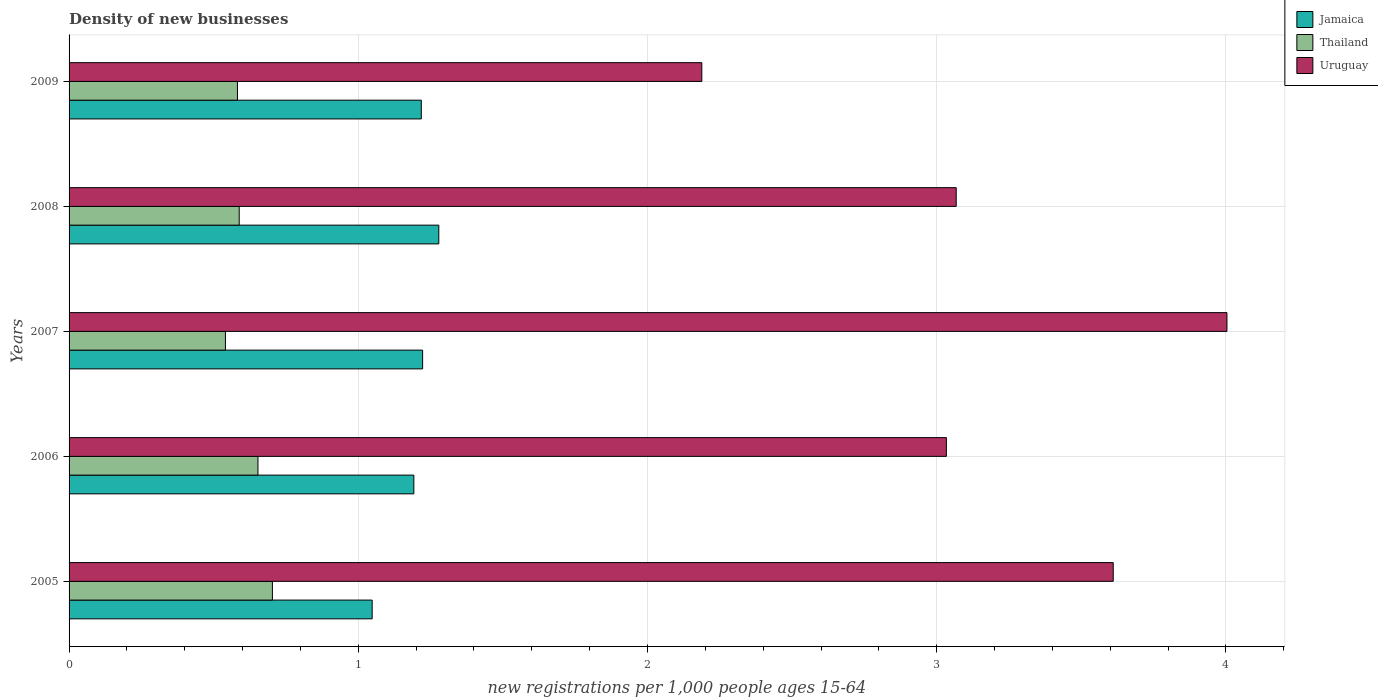How many different coloured bars are there?
Offer a very short reply. 3. Are the number of bars per tick equal to the number of legend labels?
Your response must be concise. Yes. How many bars are there on the 5th tick from the top?
Ensure brevity in your answer.  3. How many bars are there on the 1st tick from the bottom?
Keep it short and to the point. 3. In how many cases, is the number of bars for a given year not equal to the number of legend labels?
Ensure brevity in your answer.  0. What is the number of new registrations in Jamaica in 2007?
Provide a short and direct response. 1.22. Across all years, what is the maximum number of new registrations in Thailand?
Provide a short and direct response. 0.7. Across all years, what is the minimum number of new registrations in Uruguay?
Keep it short and to the point. 2.19. In which year was the number of new registrations in Jamaica maximum?
Offer a terse response. 2008. What is the total number of new registrations in Jamaica in the graph?
Keep it short and to the point. 5.96. What is the difference between the number of new registrations in Thailand in 2006 and that in 2007?
Provide a short and direct response. 0.11. What is the difference between the number of new registrations in Thailand in 2006 and the number of new registrations in Uruguay in 2009?
Give a very brief answer. -1.53. What is the average number of new registrations in Jamaica per year?
Provide a succinct answer. 1.19. In the year 2009, what is the difference between the number of new registrations in Thailand and number of new registrations in Jamaica?
Your response must be concise. -0.64. In how many years, is the number of new registrations in Jamaica greater than 3.2 ?
Your answer should be compact. 0. What is the ratio of the number of new registrations in Thailand in 2006 to that in 2007?
Provide a short and direct response. 1.21. Is the difference between the number of new registrations in Thailand in 2005 and 2008 greater than the difference between the number of new registrations in Jamaica in 2005 and 2008?
Your answer should be compact. Yes. What is the difference between the highest and the second highest number of new registrations in Uruguay?
Your answer should be very brief. 0.39. What is the difference between the highest and the lowest number of new registrations in Jamaica?
Keep it short and to the point. 0.23. What does the 1st bar from the top in 2009 represents?
Ensure brevity in your answer.  Uruguay. What does the 2nd bar from the bottom in 2006 represents?
Give a very brief answer. Thailand. Is it the case that in every year, the sum of the number of new registrations in Uruguay and number of new registrations in Thailand is greater than the number of new registrations in Jamaica?
Make the answer very short. Yes. Are all the bars in the graph horizontal?
Your answer should be compact. Yes. What is the difference between two consecutive major ticks on the X-axis?
Your answer should be very brief. 1. Does the graph contain grids?
Offer a terse response. Yes. Where does the legend appear in the graph?
Ensure brevity in your answer.  Top right. How many legend labels are there?
Your answer should be compact. 3. What is the title of the graph?
Provide a short and direct response. Density of new businesses. What is the label or title of the X-axis?
Your answer should be very brief. New registrations per 1,0 people ages 15-64. What is the new registrations per 1,000 people ages 15-64 in Jamaica in 2005?
Your response must be concise. 1.05. What is the new registrations per 1,000 people ages 15-64 of Thailand in 2005?
Provide a succinct answer. 0.7. What is the new registrations per 1,000 people ages 15-64 in Uruguay in 2005?
Provide a succinct answer. 3.61. What is the new registrations per 1,000 people ages 15-64 of Jamaica in 2006?
Give a very brief answer. 1.19. What is the new registrations per 1,000 people ages 15-64 in Thailand in 2006?
Provide a short and direct response. 0.65. What is the new registrations per 1,000 people ages 15-64 in Uruguay in 2006?
Provide a succinct answer. 3.03. What is the new registrations per 1,000 people ages 15-64 of Jamaica in 2007?
Your answer should be compact. 1.22. What is the new registrations per 1,000 people ages 15-64 of Thailand in 2007?
Your answer should be compact. 0.54. What is the new registrations per 1,000 people ages 15-64 of Uruguay in 2007?
Give a very brief answer. 4. What is the new registrations per 1,000 people ages 15-64 of Jamaica in 2008?
Make the answer very short. 1.28. What is the new registrations per 1,000 people ages 15-64 of Thailand in 2008?
Ensure brevity in your answer.  0.59. What is the new registrations per 1,000 people ages 15-64 in Uruguay in 2008?
Ensure brevity in your answer.  3.07. What is the new registrations per 1,000 people ages 15-64 in Jamaica in 2009?
Provide a succinct answer. 1.22. What is the new registrations per 1,000 people ages 15-64 in Thailand in 2009?
Make the answer very short. 0.58. What is the new registrations per 1,000 people ages 15-64 in Uruguay in 2009?
Your response must be concise. 2.19. Across all years, what is the maximum new registrations per 1,000 people ages 15-64 in Jamaica?
Provide a succinct answer. 1.28. Across all years, what is the maximum new registrations per 1,000 people ages 15-64 in Thailand?
Offer a terse response. 0.7. Across all years, what is the maximum new registrations per 1,000 people ages 15-64 of Uruguay?
Give a very brief answer. 4. Across all years, what is the minimum new registrations per 1,000 people ages 15-64 of Jamaica?
Give a very brief answer. 1.05. Across all years, what is the minimum new registrations per 1,000 people ages 15-64 in Thailand?
Make the answer very short. 0.54. Across all years, what is the minimum new registrations per 1,000 people ages 15-64 in Uruguay?
Provide a short and direct response. 2.19. What is the total new registrations per 1,000 people ages 15-64 in Jamaica in the graph?
Keep it short and to the point. 5.96. What is the total new registrations per 1,000 people ages 15-64 in Thailand in the graph?
Your answer should be compact. 3.07. What is the total new registrations per 1,000 people ages 15-64 in Uruguay in the graph?
Offer a very short reply. 15.9. What is the difference between the new registrations per 1,000 people ages 15-64 of Jamaica in 2005 and that in 2006?
Ensure brevity in your answer.  -0.14. What is the difference between the new registrations per 1,000 people ages 15-64 in Thailand in 2005 and that in 2006?
Provide a short and direct response. 0.05. What is the difference between the new registrations per 1,000 people ages 15-64 of Uruguay in 2005 and that in 2006?
Offer a very short reply. 0.58. What is the difference between the new registrations per 1,000 people ages 15-64 in Jamaica in 2005 and that in 2007?
Your answer should be very brief. -0.17. What is the difference between the new registrations per 1,000 people ages 15-64 in Thailand in 2005 and that in 2007?
Offer a very short reply. 0.16. What is the difference between the new registrations per 1,000 people ages 15-64 in Uruguay in 2005 and that in 2007?
Ensure brevity in your answer.  -0.39. What is the difference between the new registrations per 1,000 people ages 15-64 in Jamaica in 2005 and that in 2008?
Give a very brief answer. -0.23. What is the difference between the new registrations per 1,000 people ages 15-64 in Thailand in 2005 and that in 2008?
Your answer should be very brief. 0.11. What is the difference between the new registrations per 1,000 people ages 15-64 of Uruguay in 2005 and that in 2008?
Your answer should be very brief. 0.54. What is the difference between the new registrations per 1,000 people ages 15-64 in Jamaica in 2005 and that in 2009?
Ensure brevity in your answer.  -0.17. What is the difference between the new registrations per 1,000 people ages 15-64 of Thailand in 2005 and that in 2009?
Provide a short and direct response. 0.12. What is the difference between the new registrations per 1,000 people ages 15-64 of Uruguay in 2005 and that in 2009?
Make the answer very short. 1.42. What is the difference between the new registrations per 1,000 people ages 15-64 in Jamaica in 2006 and that in 2007?
Offer a terse response. -0.03. What is the difference between the new registrations per 1,000 people ages 15-64 of Thailand in 2006 and that in 2007?
Ensure brevity in your answer.  0.11. What is the difference between the new registrations per 1,000 people ages 15-64 in Uruguay in 2006 and that in 2007?
Provide a short and direct response. -0.97. What is the difference between the new registrations per 1,000 people ages 15-64 in Jamaica in 2006 and that in 2008?
Your answer should be compact. -0.09. What is the difference between the new registrations per 1,000 people ages 15-64 in Thailand in 2006 and that in 2008?
Provide a succinct answer. 0.06. What is the difference between the new registrations per 1,000 people ages 15-64 in Uruguay in 2006 and that in 2008?
Provide a short and direct response. -0.03. What is the difference between the new registrations per 1,000 people ages 15-64 in Jamaica in 2006 and that in 2009?
Offer a terse response. -0.03. What is the difference between the new registrations per 1,000 people ages 15-64 of Thailand in 2006 and that in 2009?
Your answer should be very brief. 0.07. What is the difference between the new registrations per 1,000 people ages 15-64 in Uruguay in 2006 and that in 2009?
Provide a succinct answer. 0.85. What is the difference between the new registrations per 1,000 people ages 15-64 in Jamaica in 2007 and that in 2008?
Your response must be concise. -0.06. What is the difference between the new registrations per 1,000 people ages 15-64 in Thailand in 2007 and that in 2008?
Your response must be concise. -0.05. What is the difference between the new registrations per 1,000 people ages 15-64 in Uruguay in 2007 and that in 2008?
Your response must be concise. 0.94. What is the difference between the new registrations per 1,000 people ages 15-64 in Jamaica in 2007 and that in 2009?
Your response must be concise. 0. What is the difference between the new registrations per 1,000 people ages 15-64 in Thailand in 2007 and that in 2009?
Make the answer very short. -0.04. What is the difference between the new registrations per 1,000 people ages 15-64 in Uruguay in 2007 and that in 2009?
Make the answer very short. 1.82. What is the difference between the new registrations per 1,000 people ages 15-64 in Jamaica in 2008 and that in 2009?
Offer a terse response. 0.06. What is the difference between the new registrations per 1,000 people ages 15-64 of Thailand in 2008 and that in 2009?
Make the answer very short. 0.01. What is the difference between the new registrations per 1,000 people ages 15-64 of Uruguay in 2008 and that in 2009?
Provide a short and direct response. 0.88. What is the difference between the new registrations per 1,000 people ages 15-64 of Jamaica in 2005 and the new registrations per 1,000 people ages 15-64 of Thailand in 2006?
Your response must be concise. 0.39. What is the difference between the new registrations per 1,000 people ages 15-64 in Jamaica in 2005 and the new registrations per 1,000 people ages 15-64 in Uruguay in 2006?
Make the answer very short. -1.99. What is the difference between the new registrations per 1,000 people ages 15-64 in Thailand in 2005 and the new registrations per 1,000 people ages 15-64 in Uruguay in 2006?
Your answer should be very brief. -2.33. What is the difference between the new registrations per 1,000 people ages 15-64 in Jamaica in 2005 and the new registrations per 1,000 people ages 15-64 in Thailand in 2007?
Give a very brief answer. 0.51. What is the difference between the new registrations per 1,000 people ages 15-64 in Jamaica in 2005 and the new registrations per 1,000 people ages 15-64 in Uruguay in 2007?
Provide a succinct answer. -2.96. What is the difference between the new registrations per 1,000 people ages 15-64 in Thailand in 2005 and the new registrations per 1,000 people ages 15-64 in Uruguay in 2007?
Offer a terse response. -3.3. What is the difference between the new registrations per 1,000 people ages 15-64 of Jamaica in 2005 and the new registrations per 1,000 people ages 15-64 of Thailand in 2008?
Provide a short and direct response. 0.46. What is the difference between the new registrations per 1,000 people ages 15-64 of Jamaica in 2005 and the new registrations per 1,000 people ages 15-64 of Uruguay in 2008?
Keep it short and to the point. -2.02. What is the difference between the new registrations per 1,000 people ages 15-64 of Thailand in 2005 and the new registrations per 1,000 people ages 15-64 of Uruguay in 2008?
Provide a succinct answer. -2.36. What is the difference between the new registrations per 1,000 people ages 15-64 of Jamaica in 2005 and the new registrations per 1,000 people ages 15-64 of Thailand in 2009?
Your answer should be very brief. 0.47. What is the difference between the new registrations per 1,000 people ages 15-64 in Jamaica in 2005 and the new registrations per 1,000 people ages 15-64 in Uruguay in 2009?
Ensure brevity in your answer.  -1.14. What is the difference between the new registrations per 1,000 people ages 15-64 of Thailand in 2005 and the new registrations per 1,000 people ages 15-64 of Uruguay in 2009?
Provide a succinct answer. -1.48. What is the difference between the new registrations per 1,000 people ages 15-64 in Jamaica in 2006 and the new registrations per 1,000 people ages 15-64 in Thailand in 2007?
Your answer should be very brief. 0.65. What is the difference between the new registrations per 1,000 people ages 15-64 of Jamaica in 2006 and the new registrations per 1,000 people ages 15-64 of Uruguay in 2007?
Your answer should be compact. -2.81. What is the difference between the new registrations per 1,000 people ages 15-64 of Thailand in 2006 and the new registrations per 1,000 people ages 15-64 of Uruguay in 2007?
Ensure brevity in your answer.  -3.35. What is the difference between the new registrations per 1,000 people ages 15-64 in Jamaica in 2006 and the new registrations per 1,000 people ages 15-64 in Thailand in 2008?
Offer a terse response. 0.6. What is the difference between the new registrations per 1,000 people ages 15-64 in Jamaica in 2006 and the new registrations per 1,000 people ages 15-64 in Uruguay in 2008?
Offer a very short reply. -1.88. What is the difference between the new registrations per 1,000 people ages 15-64 in Thailand in 2006 and the new registrations per 1,000 people ages 15-64 in Uruguay in 2008?
Offer a terse response. -2.41. What is the difference between the new registrations per 1,000 people ages 15-64 in Jamaica in 2006 and the new registrations per 1,000 people ages 15-64 in Thailand in 2009?
Your answer should be compact. 0.61. What is the difference between the new registrations per 1,000 people ages 15-64 in Jamaica in 2006 and the new registrations per 1,000 people ages 15-64 in Uruguay in 2009?
Offer a terse response. -1. What is the difference between the new registrations per 1,000 people ages 15-64 of Thailand in 2006 and the new registrations per 1,000 people ages 15-64 of Uruguay in 2009?
Your answer should be compact. -1.53. What is the difference between the new registrations per 1,000 people ages 15-64 in Jamaica in 2007 and the new registrations per 1,000 people ages 15-64 in Thailand in 2008?
Provide a succinct answer. 0.63. What is the difference between the new registrations per 1,000 people ages 15-64 of Jamaica in 2007 and the new registrations per 1,000 people ages 15-64 of Uruguay in 2008?
Keep it short and to the point. -1.84. What is the difference between the new registrations per 1,000 people ages 15-64 of Thailand in 2007 and the new registrations per 1,000 people ages 15-64 of Uruguay in 2008?
Give a very brief answer. -2.53. What is the difference between the new registrations per 1,000 people ages 15-64 in Jamaica in 2007 and the new registrations per 1,000 people ages 15-64 in Thailand in 2009?
Make the answer very short. 0.64. What is the difference between the new registrations per 1,000 people ages 15-64 of Jamaica in 2007 and the new registrations per 1,000 people ages 15-64 of Uruguay in 2009?
Provide a succinct answer. -0.97. What is the difference between the new registrations per 1,000 people ages 15-64 of Thailand in 2007 and the new registrations per 1,000 people ages 15-64 of Uruguay in 2009?
Your answer should be very brief. -1.65. What is the difference between the new registrations per 1,000 people ages 15-64 in Jamaica in 2008 and the new registrations per 1,000 people ages 15-64 in Thailand in 2009?
Your response must be concise. 0.7. What is the difference between the new registrations per 1,000 people ages 15-64 in Jamaica in 2008 and the new registrations per 1,000 people ages 15-64 in Uruguay in 2009?
Provide a short and direct response. -0.91. What is the difference between the new registrations per 1,000 people ages 15-64 in Thailand in 2008 and the new registrations per 1,000 people ages 15-64 in Uruguay in 2009?
Make the answer very short. -1.6. What is the average new registrations per 1,000 people ages 15-64 of Jamaica per year?
Give a very brief answer. 1.19. What is the average new registrations per 1,000 people ages 15-64 of Thailand per year?
Ensure brevity in your answer.  0.61. What is the average new registrations per 1,000 people ages 15-64 in Uruguay per year?
Give a very brief answer. 3.18. In the year 2005, what is the difference between the new registrations per 1,000 people ages 15-64 in Jamaica and new registrations per 1,000 people ages 15-64 in Thailand?
Ensure brevity in your answer.  0.34. In the year 2005, what is the difference between the new registrations per 1,000 people ages 15-64 of Jamaica and new registrations per 1,000 people ages 15-64 of Uruguay?
Provide a short and direct response. -2.56. In the year 2005, what is the difference between the new registrations per 1,000 people ages 15-64 of Thailand and new registrations per 1,000 people ages 15-64 of Uruguay?
Make the answer very short. -2.91. In the year 2006, what is the difference between the new registrations per 1,000 people ages 15-64 in Jamaica and new registrations per 1,000 people ages 15-64 in Thailand?
Offer a very short reply. 0.54. In the year 2006, what is the difference between the new registrations per 1,000 people ages 15-64 in Jamaica and new registrations per 1,000 people ages 15-64 in Uruguay?
Provide a succinct answer. -1.84. In the year 2006, what is the difference between the new registrations per 1,000 people ages 15-64 in Thailand and new registrations per 1,000 people ages 15-64 in Uruguay?
Offer a very short reply. -2.38. In the year 2007, what is the difference between the new registrations per 1,000 people ages 15-64 in Jamaica and new registrations per 1,000 people ages 15-64 in Thailand?
Keep it short and to the point. 0.68. In the year 2007, what is the difference between the new registrations per 1,000 people ages 15-64 in Jamaica and new registrations per 1,000 people ages 15-64 in Uruguay?
Your answer should be compact. -2.78. In the year 2007, what is the difference between the new registrations per 1,000 people ages 15-64 in Thailand and new registrations per 1,000 people ages 15-64 in Uruguay?
Offer a very short reply. -3.46. In the year 2008, what is the difference between the new registrations per 1,000 people ages 15-64 in Jamaica and new registrations per 1,000 people ages 15-64 in Thailand?
Your answer should be compact. 0.69. In the year 2008, what is the difference between the new registrations per 1,000 people ages 15-64 in Jamaica and new registrations per 1,000 people ages 15-64 in Uruguay?
Provide a short and direct response. -1.79. In the year 2008, what is the difference between the new registrations per 1,000 people ages 15-64 of Thailand and new registrations per 1,000 people ages 15-64 of Uruguay?
Your answer should be very brief. -2.48. In the year 2009, what is the difference between the new registrations per 1,000 people ages 15-64 in Jamaica and new registrations per 1,000 people ages 15-64 in Thailand?
Give a very brief answer. 0.64. In the year 2009, what is the difference between the new registrations per 1,000 people ages 15-64 in Jamaica and new registrations per 1,000 people ages 15-64 in Uruguay?
Ensure brevity in your answer.  -0.97. In the year 2009, what is the difference between the new registrations per 1,000 people ages 15-64 of Thailand and new registrations per 1,000 people ages 15-64 of Uruguay?
Make the answer very short. -1.61. What is the ratio of the new registrations per 1,000 people ages 15-64 of Jamaica in 2005 to that in 2006?
Your response must be concise. 0.88. What is the ratio of the new registrations per 1,000 people ages 15-64 of Thailand in 2005 to that in 2006?
Make the answer very short. 1.08. What is the ratio of the new registrations per 1,000 people ages 15-64 of Uruguay in 2005 to that in 2006?
Provide a succinct answer. 1.19. What is the ratio of the new registrations per 1,000 people ages 15-64 of Jamaica in 2005 to that in 2007?
Ensure brevity in your answer.  0.86. What is the ratio of the new registrations per 1,000 people ages 15-64 in Thailand in 2005 to that in 2007?
Offer a terse response. 1.3. What is the ratio of the new registrations per 1,000 people ages 15-64 of Uruguay in 2005 to that in 2007?
Ensure brevity in your answer.  0.9. What is the ratio of the new registrations per 1,000 people ages 15-64 in Jamaica in 2005 to that in 2008?
Offer a very short reply. 0.82. What is the ratio of the new registrations per 1,000 people ages 15-64 of Thailand in 2005 to that in 2008?
Your response must be concise. 1.2. What is the ratio of the new registrations per 1,000 people ages 15-64 of Uruguay in 2005 to that in 2008?
Offer a very short reply. 1.18. What is the ratio of the new registrations per 1,000 people ages 15-64 of Jamaica in 2005 to that in 2009?
Provide a succinct answer. 0.86. What is the ratio of the new registrations per 1,000 people ages 15-64 in Thailand in 2005 to that in 2009?
Make the answer very short. 1.21. What is the ratio of the new registrations per 1,000 people ages 15-64 in Uruguay in 2005 to that in 2009?
Your answer should be very brief. 1.65. What is the ratio of the new registrations per 1,000 people ages 15-64 of Jamaica in 2006 to that in 2007?
Your answer should be compact. 0.98. What is the ratio of the new registrations per 1,000 people ages 15-64 in Thailand in 2006 to that in 2007?
Keep it short and to the point. 1.21. What is the ratio of the new registrations per 1,000 people ages 15-64 in Uruguay in 2006 to that in 2007?
Ensure brevity in your answer.  0.76. What is the ratio of the new registrations per 1,000 people ages 15-64 of Jamaica in 2006 to that in 2008?
Keep it short and to the point. 0.93. What is the ratio of the new registrations per 1,000 people ages 15-64 in Thailand in 2006 to that in 2008?
Your response must be concise. 1.11. What is the ratio of the new registrations per 1,000 people ages 15-64 of Uruguay in 2006 to that in 2008?
Your answer should be very brief. 0.99. What is the ratio of the new registrations per 1,000 people ages 15-64 of Jamaica in 2006 to that in 2009?
Offer a very short reply. 0.98. What is the ratio of the new registrations per 1,000 people ages 15-64 in Thailand in 2006 to that in 2009?
Provide a short and direct response. 1.12. What is the ratio of the new registrations per 1,000 people ages 15-64 of Uruguay in 2006 to that in 2009?
Keep it short and to the point. 1.39. What is the ratio of the new registrations per 1,000 people ages 15-64 of Jamaica in 2007 to that in 2008?
Give a very brief answer. 0.96. What is the ratio of the new registrations per 1,000 people ages 15-64 in Thailand in 2007 to that in 2008?
Your response must be concise. 0.92. What is the ratio of the new registrations per 1,000 people ages 15-64 in Uruguay in 2007 to that in 2008?
Your answer should be compact. 1.31. What is the ratio of the new registrations per 1,000 people ages 15-64 of Jamaica in 2007 to that in 2009?
Offer a very short reply. 1. What is the ratio of the new registrations per 1,000 people ages 15-64 of Thailand in 2007 to that in 2009?
Provide a succinct answer. 0.93. What is the ratio of the new registrations per 1,000 people ages 15-64 of Uruguay in 2007 to that in 2009?
Offer a terse response. 1.83. What is the ratio of the new registrations per 1,000 people ages 15-64 in Jamaica in 2008 to that in 2009?
Offer a very short reply. 1.05. What is the ratio of the new registrations per 1,000 people ages 15-64 in Thailand in 2008 to that in 2009?
Ensure brevity in your answer.  1.01. What is the ratio of the new registrations per 1,000 people ages 15-64 in Uruguay in 2008 to that in 2009?
Ensure brevity in your answer.  1.4. What is the difference between the highest and the second highest new registrations per 1,000 people ages 15-64 of Jamaica?
Offer a terse response. 0.06. What is the difference between the highest and the second highest new registrations per 1,000 people ages 15-64 of Thailand?
Ensure brevity in your answer.  0.05. What is the difference between the highest and the second highest new registrations per 1,000 people ages 15-64 of Uruguay?
Provide a succinct answer. 0.39. What is the difference between the highest and the lowest new registrations per 1,000 people ages 15-64 of Jamaica?
Keep it short and to the point. 0.23. What is the difference between the highest and the lowest new registrations per 1,000 people ages 15-64 in Thailand?
Your response must be concise. 0.16. What is the difference between the highest and the lowest new registrations per 1,000 people ages 15-64 in Uruguay?
Offer a very short reply. 1.82. 